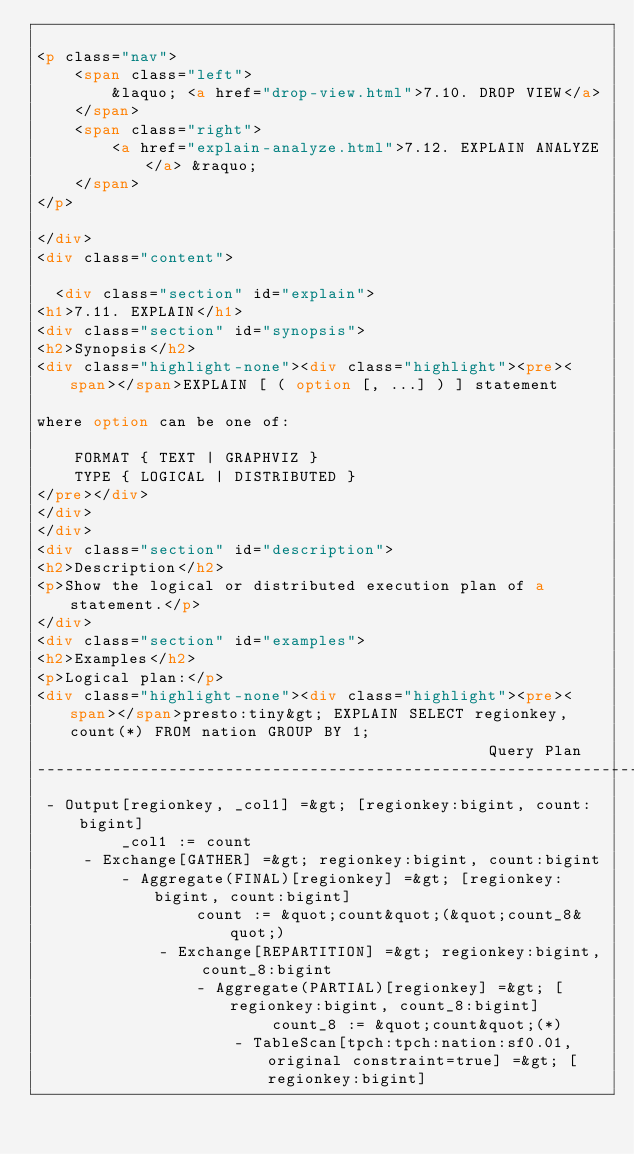<code> <loc_0><loc_0><loc_500><loc_500><_HTML_>    
<p class="nav">
    <span class="left">
        &laquo; <a href="drop-view.html">7.10. DROP VIEW</a>
    </span>
    <span class="right">
        <a href="explain-analyze.html">7.12. EXPLAIN ANALYZE</a> &raquo;
    </span>
</p>

</div>
<div class="content">
    
  <div class="section" id="explain">
<h1>7.11. EXPLAIN</h1>
<div class="section" id="synopsis">
<h2>Synopsis</h2>
<div class="highlight-none"><div class="highlight"><pre><span></span>EXPLAIN [ ( option [, ...] ) ] statement

where option can be one of:

    FORMAT { TEXT | GRAPHVIZ }
    TYPE { LOGICAL | DISTRIBUTED }
</pre></div>
</div>
</div>
<div class="section" id="description">
<h2>Description</h2>
<p>Show the logical or distributed execution plan of a statement.</p>
</div>
<div class="section" id="examples">
<h2>Examples</h2>
<p>Logical plan:</p>
<div class="highlight-none"><div class="highlight"><pre><span></span>presto:tiny&gt; EXPLAIN SELECT regionkey, count(*) FROM nation GROUP BY 1;
                                                Query Plan
----------------------------------------------------------------------------------------------------------
 - Output[regionkey, _col1] =&gt; [regionkey:bigint, count:bigint]
         _col1 := count
     - Exchange[GATHER] =&gt; regionkey:bigint, count:bigint
         - Aggregate(FINAL)[regionkey] =&gt; [regionkey:bigint, count:bigint]
                 count := &quot;count&quot;(&quot;count_8&quot;)
             - Exchange[REPARTITION] =&gt; regionkey:bigint, count_8:bigint
                 - Aggregate(PARTIAL)[regionkey] =&gt; [regionkey:bigint, count_8:bigint]
                         count_8 := &quot;count&quot;(*)
                     - TableScan[tpch:tpch:nation:sf0.01, original constraint=true] =&gt; [regionkey:bigint]</code> 